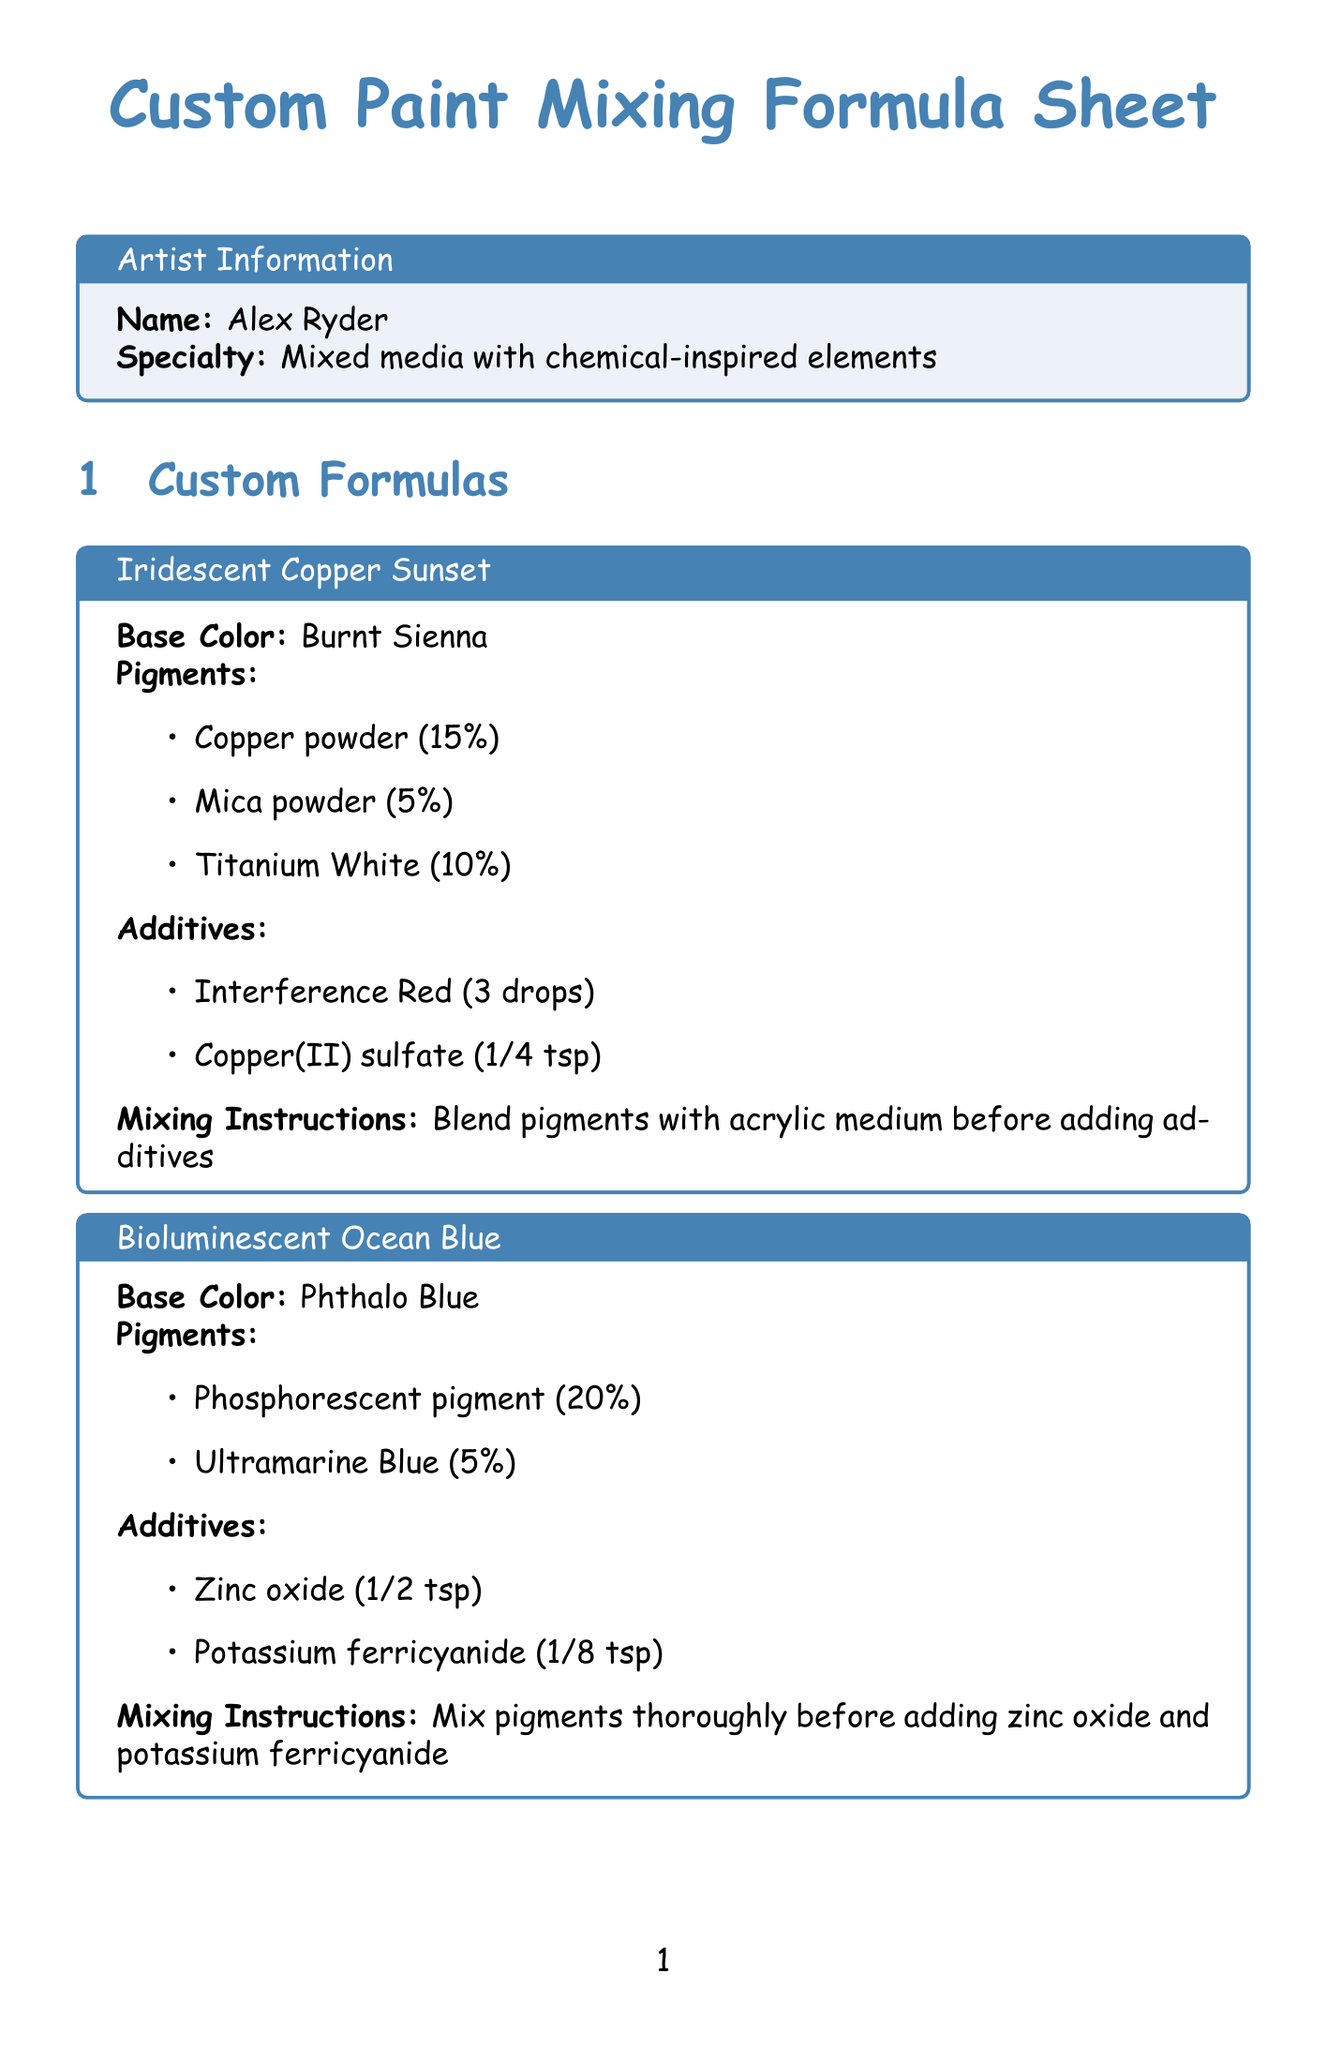What is the name of the artist? The document states the artist's name at the beginning as Alex Ryder.
Answer: Alex Ryder What is the base color for Iridescent Copper Sunset? This information is located under the "Custom Formulas" section specifically for the Iridescent Copper Sunset formula.
Answer: Burnt Sienna How much Copper powder is used in the Iridescent Copper Sunset formula? The formula details the ratio of Copper powder under the pigments section, which is listed as 15%.
Answer: 15% What is the amount of Zinc oxide in the Bioluminescent Ocean Blue formula? This is found in the additives section of the Bioluminescent Ocean Blue formula, indicating the specific amount required.
Answer: 1/2 tsp Which safety guideline advises wearing protective equipment? The guidelines include specific recommendations about safety precautions to be taken while working with chemical additives.
Answer: Always wear protective gloves and a mask when handling chemical additives What type of chemicals are involved in the Reactive Lava Flow? The relevant section indicates both pigments and additives that contribute to this formula, hence identifying the chemical nature involved.
Answer: Iron oxide red, Carbon black, Aluminum powder, Potassium permanganate What is the specialty of Kremer Pigments? The recommended suppliers section includes specialties of different pigment suppliers, identifying that of Kremer Pigments.
Answer: Historical and rare pigments Which inspirational chemical reaction involves blue glow? The reactions are listed and described for creative inspiration purposes, highlighting the specific reaction associated with the blue glow.
Answer: Fluorescence of quinine What can mixed paints be stored in? The safety guidelines explain proper storage techniques for mixed paints.
Answer: Airtight containers 